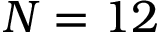Convert formula to latex. <formula><loc_0><loc_0><loc_500><loc_500>N = 1 2</formula> 